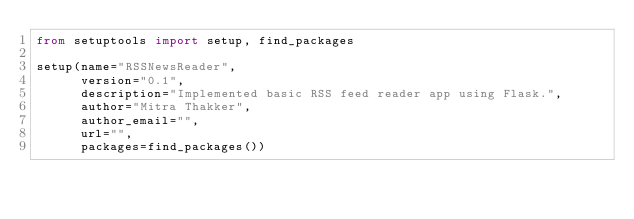Convert code to text. <code><loc_0><loc_0><loc_500><loc_500><_Python_>from setuptools import setup, find_packages

setup(name="RSSNewsReader",
      version="0.1",
      description="Implemented basic RSS feed reader app using Flask.",
      author="Mitra Thakker",
      author_email="",
      url="",
      packages=find_packages())
</code> 